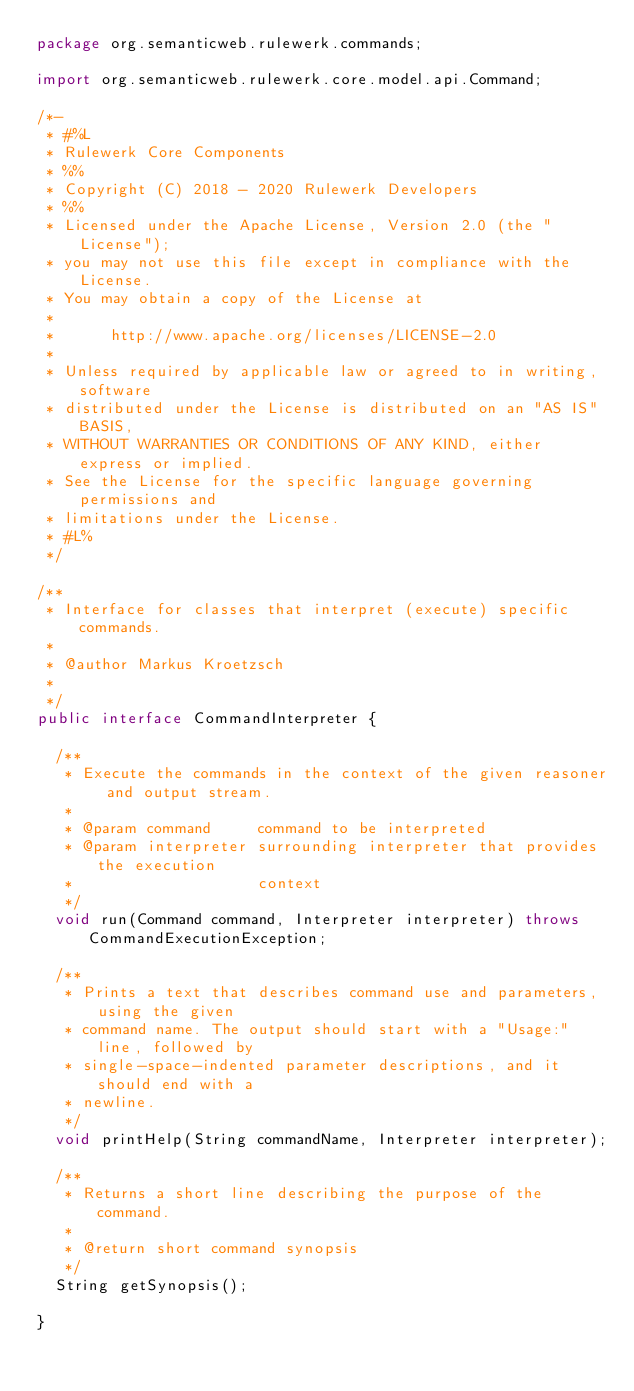<code> <loc_0><loc_0><loc_500><loc_500><_Java_>package org.semanticweb.rulewerk.commands;

import org.semanticweb.rulewerk.core.model.api.Command;

/*-
 * #%L
 * Rulewerk Core Components
 * %%
 * Copyright (C) 2018 - 2020 Rulewerk Developers
 * %%
 * Licensed under the Apache License, Version 2.0 (the "License");
 * you may not use this file except in compliance with the License.
 * You may obtain a copy of the License at
 * 
 *      http://www.apache.org/licenses/LICENSE-2.0
 * 
 * Unless required by applicable law or agreed to in writing, software
 * distributed under the License is distributed on an "AS IS" BASIS,
 * WITHOUT WARRANTIES OR CONDITIONS OF ANY KIND, either express or implied.
 * See the License for the specific language governing permissions and
 * limitations under the License.
 * #L%
 */

/**
 * Interface for classes that interpret (execute) specific commands.
 * 
 * @author Markus Kroetzsch
 *
 */
public interface CommandInterpreter {

	/**
	 * Execute the commands in the context of the given reasoner and output stream.
	 * 
	 * @param command     command to be interpreted
	 * @param interpreter surrounding interpreter that provides the execution
	 *                    context
	 */
	void run(Command command, Interpreter interpreter) throws CommandExecutionException;

	/**
	 * Prints a text that describes command use and parameters, using the given
	 * command name. The output should start with a "Usage:" line, followed by
	 * single-space-indented parameter descriptions, and it should end with a
	 * newline.
	 */
	void printHelp(String commandName, Interpreter interpreter);

	/**
	 * Returns a short line describing the purpose of the command.
	 * 
	 * @return short command synopsis
	 */
	String getSynopsis();

}
</code> 